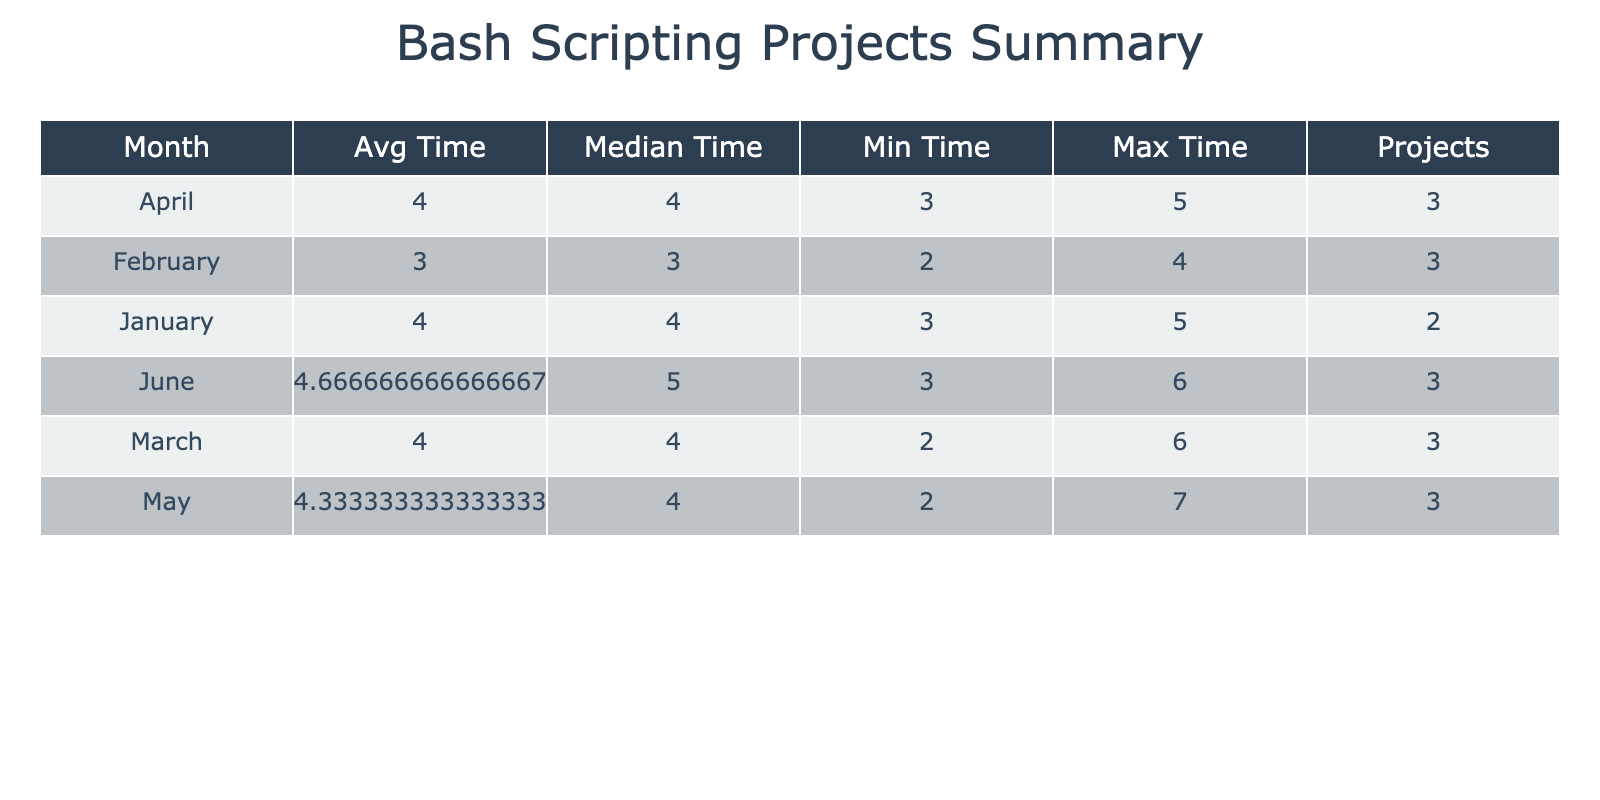What is the maximum completion time for projects in March? In March, the completion times for projects are 6, 4, and 2 hours. The maximum of these values is 6 hours.
Answer: 6 How many projects were completed in April? In April, the number of projects is counted as three: Network Traffic Monitor, File Synchronization Script, and Disk Space Cleaner.
Answer: 3 What is the average time taken for all projects completed in February? In February, the completion times are 4, 2, and 3 hours. The average is calculated by summing these values (4 + 2 + 3 = 9) and dividing by the number of projects (9/3 = 3).
Answer: 3 Did any student complete a project in January that took less than four hours? Referring to the projects in January, there is one project by Alice Johnson that took 3 hours, which is less than four hours.
Answer: Yes Which month had the highest average completion time for projects? To determine the highest average completion time, we look at the averages for each month: January (4), February (3), March (4), April (4), May (4.33), and June (4.67). The highest average is 4.67 in June.
Answer: June What is the total completion time for projects in May? In May, the completion times are 7, 4, and 2 hours. The total is calculated by adding these times together (7 + 4 + 2 = 13).
Answer: 13 Is there a project completed in February that has a complexity level of High? Checking the projects listed for February, none of them indicate a complexity level of High. Therefore, the answer is no.
Answer: No Which student completed the most complex project in the dataset? The most complex projects, classified as High, are completed by Bob Smith, Michael Taylor, James Anderson, and Isabella Lee. Each completed one project, so all are tied for this.
Answer: Multiple (Bob Smith, Michael Taylor, James Anderson, Isabella Lee) What is the range of completion times for projects in June? The completion times in June are 5, 3, and 6 hours. The range is calculated as the maximum time minus the minimum time (6 - 3 = 3).
Answer: 3 